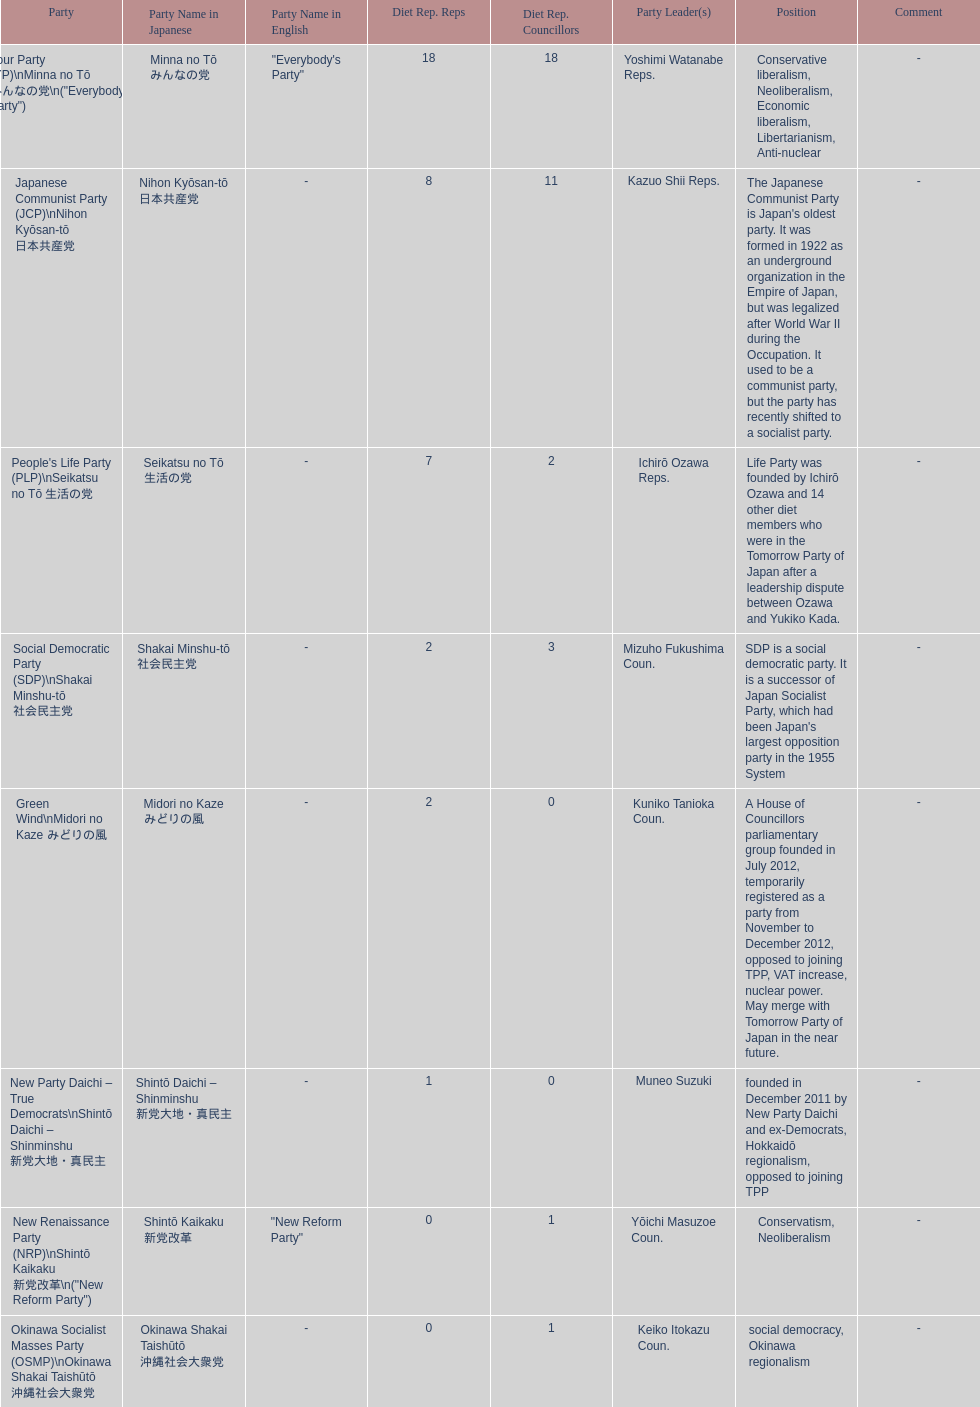Parse the full table. {'header': ['Party', 'Party Name in Japanese', 'Party Name in English', 'Diet Rep. Reps', 'Diet Rep. Councillors', 'Party Leader(s)', 'Position', 'Comment'], 'rows': [['Your Party (YP)\\nMinna no Tō みんなの党\\n("Everybody\'s Party")', 'Minna no Tō みんなの党', '"Everybody\'s Party"', '18', '18', 'Yoshimi Watanabe Reps.', 'Conservative liberalism, Neoliberalism, Economic liberalism, Libertarianism, Anti-nuclear', '-'], ['Japanese Communist Party (JCP)\\nNihon Kyōsan-tō 日本共産党', 'Nihon Kyōsan-tō 日本共産党', '-', '8', '11', 'Kazuo Shii Reps.', "The Japanese Communist Party is Japan's oldest party. It was formed in 1922 as an underground organization in the Empire of Japan, but was legalized after World War II during the Occupation. It used to be a communist party, but the party has recently shifted to a socialist party.", '-'], ["People's Life Party (PLP)\\nSeikatsu no Tō 生活の党", 'Seikatsu no Tō 生活の党', '-', '7', '2', 'Ichirō Ozawa Reps.', 'Life Party was founded by Ichirō Ozawa and 14 other diet members who were in the Tomorrow Party of Japan after a leadership dispute between Ozawa and Yukiko Kada.', '-'], ['Social Democratic Party (SDP)\\nShakai Minshu-tō 社会民主党', 'Shakai Minshu-tō 社会民主党', '-', '2', '3', 'Mizuho Fukushima Coun.', "SDP is a social democratic party. It is a successor of Japan Socialist Party, which had been Japan's largest opposition party in the 1955 System", '-'], ['Green Wind\\nMidori no Kaze みどりの風', 'Midori no Kaze みどりの風', '-', '2', '0', 'Kuniko Tanioka Coun.', 'A House of Councillors parliamentary group founded in July 2012, temporarily registered as a party from November to December 2012, opposed to joining TPP, VAT increase, nuclear power. May merge with Tomorrow Party of Japan in the near future.', '-'], ['New Party Daichi – True Democrats\\nShintō Daichi – Shinminshu 新党大地・真民主', 'Shintō Daichi – Shinminshu 新党大地・真民主', '-', '1', '0', 'Muneo Suzuki', 'founded in December 2011 by New Party Daichi and ex-Democrats, Hokkaidō regionalism, opposed to joining TPP', '-'], ['New Renaissance Party (NRP)\\nShintō Kaikaku 新党改革\\n("New Reform Party")', 'Shintō Kaikaku 新党改革', '"New Reform Party"', '0', '1', 'Yōichi Masuzoe Coun.', 'Conservatism, Neoliberalism', '-'], ['Okinawa Socialist Masses Party (OSMP)\\nOkinawa Shakai Taishūtō 沖縄社会大衆党', 'Okinawa Shakai Taishūtō 沖縄社会大衆党', '-', '0', '1', 'Keiko Itokazu Coun.', 'social democracy, Okinawa regionalism', '-']]} What party has the most representatives in the diet representation? Your Party. 